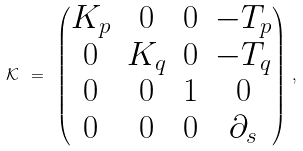<formula> <loc_0><loc_0><loc_500><loc_500>\mathcal { K } \ = \ \begin{pmatrix} K _ { p } & 0 & 0 & - T _ { p } \\ 0 & K _ { q } & 0 & - T _ { q } \\ 0 & 0 & 1 & 0 \\ 0 & 0 & 0 & \partial _ { s } \end{pmatrix} \, ,</formula> 